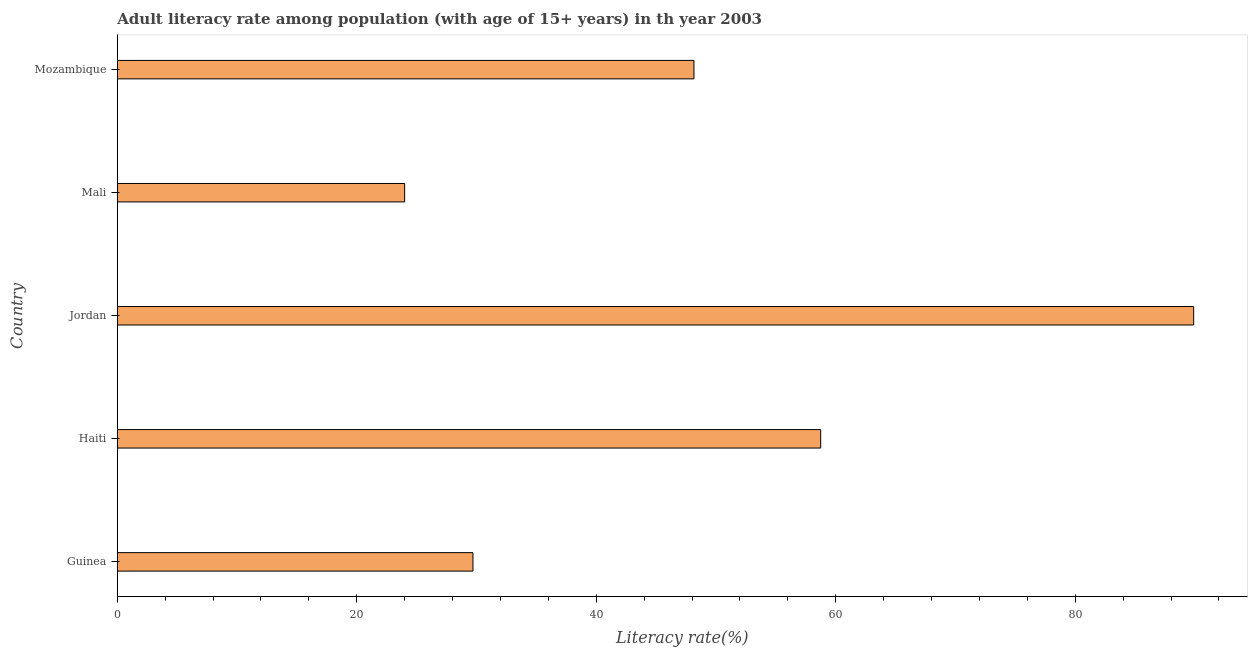Does the graph contain any zero values?
Your answer should be compact. No. Does the graph contain grids?
Make the answer very short. No. What is the title of the graph?
Ensure brevity in your answer.  Adult literacy rate among population (with age of 15+ years) in th year 2003. What is the label or title of the X-axis?
Offer a very short reply. Literacy rate(%). What is the label or title of the Y-axis?
Provide a succinct answer. Country. What is the adult literacy rate in Mali?
Your answer should be very brief. 24. Across all countries, what is the maximum adult literacy rate?
Provide a short and direct response. 89.89. Across all countries, what is the minimum adult literacy rate?
Give a very brief answer. 24. In which country was the adult literacy rate maximum?
Offer a very short reply. Jordan. In which country was the adult literacy rate minimum?
Provide a short and direct response. Mali. What is the sum of the adult literacy rate?
Ensure brevity in your answer.  250.5. What is the difference between the adult literacy rate in Jordan and Mozambique?
Ensure brevity in your answer.  41.73. What is the average adult literacy rate per country?
Your answer should be very brief. 50.1. What is the median adult literacy rate?
Provide a succinct answer. 48.16. What is the ratio of the adult literacy rate in Guinea to that in Haiti?
Give a very brief answer. 0.51. What is the difference between the highest and the second highest adult literacy rate?
Give a very brief answer. 31.15. What is the difference between the highest and the lowest adult literacy rate?
Keep it short and to the point. 65.89. How many countries are there in the graph?
Provide a short and direct response. 5. Are the values on the major ticks of X-axis written in scientific E-notation?
Offer a very short reply. No. What is the Literacy rate(%) in Guinea?
Give a very brief answer. 29.7. What is the Literacy rate(%) of Haiti?
Provide a succinct answer. 58.74. What is the Literacy rate(%) in Jordan?
Provide a short and direct response. 89.89. What is the Literacy rate(%) in Mozambique?
Your answer should be compact. 48.16. What is the difference between the Literacy rate(%) in Guinea and Haiti?
Make the answer very short. -29.04. What is the difference between the Literacy rate(%) in Guinea and Jordan?
Provide a short and direct response. -60.19. What is the difference between the Literacy rate(%) in Guinea and Mali?
Your response must be concise. 5.7. What is the difference between the Literacy rate(%) in Guinea and Mozambique?
Your response must be concise. -18.45. What is the difference between the Literacy rate(%) in Haiti and Jordan?
Provide a succinct answer. -31.15. What is the difference between the Literacy rate(%) in Haiti and Mali?
Offer a terse response. 34.74. What is the difference between the Literacy rate(%) in Haiti and Mozambique?
Your answer should be compact. 10.59. What is the difference between the Literacy rate(%) in Jordan and Mali?
Make the answer very short. 65.89. What is the difference between the Literacy rate(%) in Jordan and Mozambique?
Provide a short and direct response. 41.73. What is the difference between the Literacy rate(%) in Mali and Mozambique?
Your answer should be very brief. -24.16. What is the ratio of the Literacy rate(%) in Guinea to that in Haiti?
Provide a short and direct response. 0.51. What is the ratio of the Literacy rate(%) in Guinea to that in Jordan?
Provide a short and direct response. 0.33. What is the ratio of the Literacy rate(%) in Guinea to that in Mali?
Offer a terse response. 1.24. What is the ratio of the Literacy rate(%) in Guinea to that in Mozambique?
Your response must be concise. 0.62. What is the ratio of the Literacy rate(%) in Haiti to that in Jordan?
Your response must be concise. 0.65. What is the ratio of the Literacy rate(%) in Haiti to that in Mali?
Give a very brief answer. 2.45. What is the ratio of the Literacy rate(%) in Haiti to that in Mozambique?
Your answer should be very brief. 1.22. What is the ratio of the Literacy rate(%) in Jordan to that in Mali?
Keep it short and to the point. 3.75. What is the ratio of the Literacy rate(%) in Jordan to that in Mozambique?
Your answer should be compact. 1.87. What is the ratio of the Literacy rate(%) in Mali to that in Mozambique?
Ensure brevity in your answer.  0.5. 